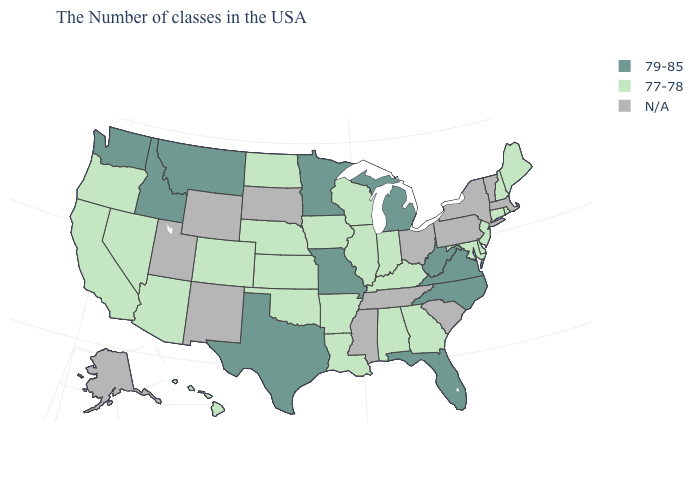What is the value of Hawaii?
Give a very brief answer. 77-78. What is the value of Mississippi?
Quick response, please. N/A. Which states have the lowest value in the USA?
Quick response, please. Maine, Rhode Island, New Hampshire, Connecticut, New Jersey, Delaware, Maryland, Georgia, Kentucky, Indiana, Alabama, Wisconsin, Illinois, Louisiana, Arkansas, Iowa, Kansas, Nebraska, Oklahoma, North Dakota, Colorado, Arizona, Nevada, California, Oregon, Hawaii. Name the states that have a value in the range 77-78?
Keep it brief. Maine, Rhode Island, New Hampshire, Connecticut, New Jersey, Delaware, Maryland, Georgia, Kentucky, Indiana, Alabama, Wisconsin, Illinois, Louisiana, Arkansas, Iowa, Kansas, Nebraska, Oklahoma, North Dakota, Colorado, Arizona, Nevada, California, Oregon, Hawaii. Which states have the lowest value in the USA?
Keep it brief. Maine, Rhode Island, New Hampshire, Connecticut, New Jersey, Delaware, Maryland, Georgia, Kentucky, Indiana, Alabama, Wisconsin, Illinois, Louisiana, Arkansas, Iowa, Kansas, Nebraska, Oklahoma, North Dakota, Colorado, Arizona, Nevada, California, Oregon, Hawaii. What is the lowest value in the South?
Give a very brief answer. 77-78. Among the states that border Louisiana , which have the lowest value?
Give a very brief answer. Arkansas. Name the states that have a value in the range 79-85?
Short answer required. Virginia, North Carolina, West Virginia, Florida, Michigan, Missouri, Minnesota, Texas, Montana, Idaho, Washington. What is the lowest value in the USA?
Quick response, please. 77-78. Is the legend a continuous bar?
Keep it brief. No. What is the lowest value in the Northeast?
Quick response, please. 77-78. What is the highest value in the Northeast ?
Keep it brief. 77-78. Name the states that have a value in the range N/A?
Give a very brief answer. Massachusetts, Vermont, New York, Pennsylvania, South Carolina, Ohio, Tennessee, Mississippi, South Dakota, Wyoming, New Mexico, Utah, Alaska. Name the states that have a value in the range N/A?
Write a very short answer. Massachusetts, Vermont, New York, Pennsylvania, South Carolina, Ohio, Tennessee, Mississippi, South Dakota, Wyoming, New Mexico, Utah, Alaska. 